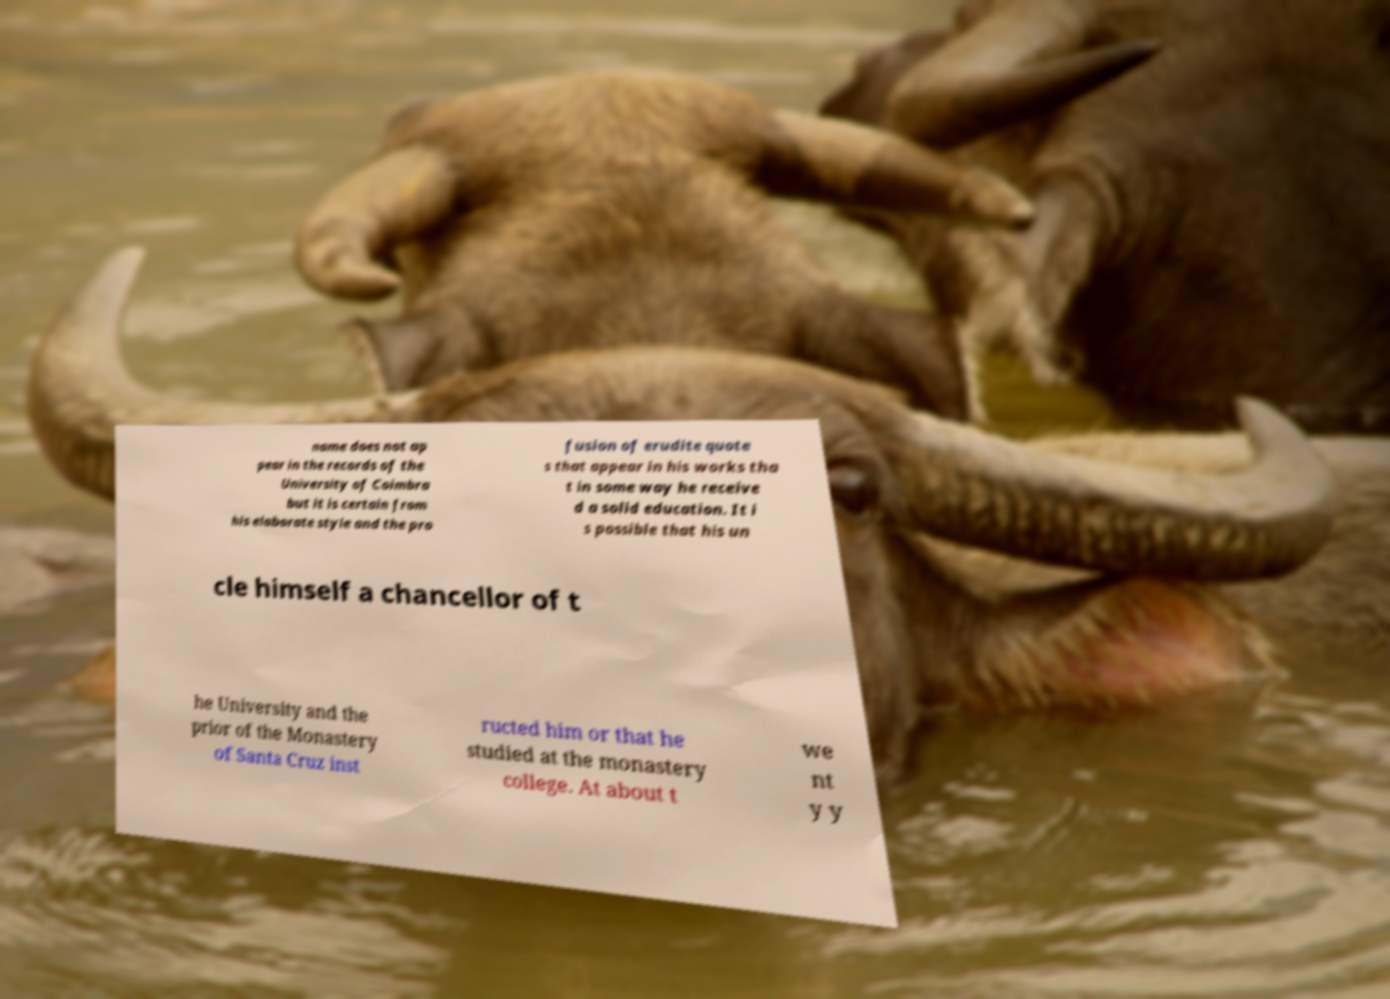Can you read and provide the text displayed in the image?This photo seems to have some interesting text. Can you extract and type it out for me? name does not ap pear in the records of the University of Coimbra but it is certain from his elaborate style and the pro fusion of erudite quote s that appear in his works tha t in some way he receive d a solid education. It i s possible that his un cle himself a chancellor of t he University and the prior of the Monastery of Santa Cruz inst ructed him or that he studied at the monastery college. At about t we nt y y 